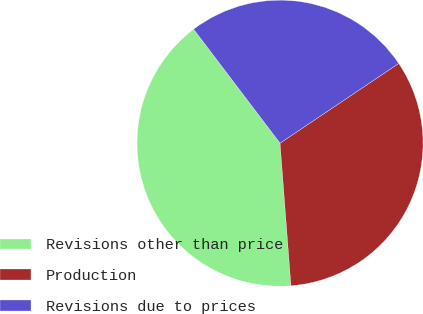Convert chart to OTSL. <chart><loc_0><loc_0><loc_500><loc_500><pie_chart><fcel>Revisions other than price<fcel>Production<fcel>Revisions due to prices<nl><fcel>40.89%<fcel>33.2%<fcel>25.91%<nl></chart> 